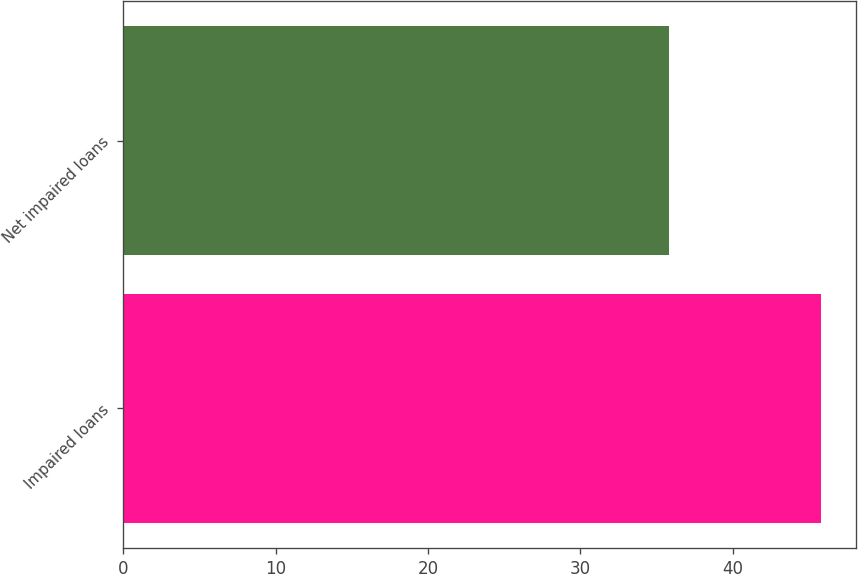<chart> <loc_0><loc_0><loc_500><loc_500><bar_chart><fcel>Impaired loans<fcel>Net impaired loans<nl><fcel>45.8<fcel>35.8<nl></chart> 